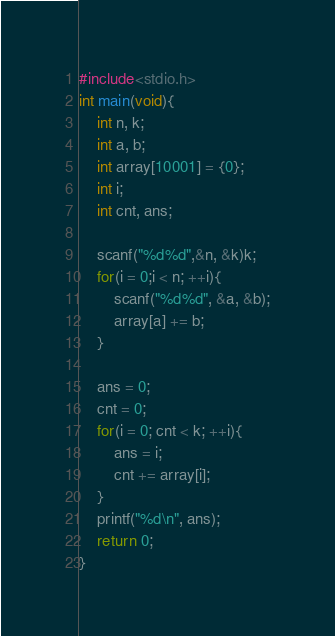Convert code to text. <code><loc_0><loc_0><loc_500><loc_500><_C_>#include<stdio.h>
int main(void){
	int n, k;
	int a, b;
	int array[10001] = {0};
	int i;
	int cnt, ans;

	scanf("%d%d",&n, &k)k;
	for(i = 0;i < n; ++i){
		scanf("%d%d", &a, &b);
		array[a] += b;
	}

	ans = 0;
	cnt = 0;
	for(i = 0; cnt < k; ++i){
		ans = i;
		cnt += array[i];
	}
	printf("%d\n", ans);
	return 0;
}</code> 